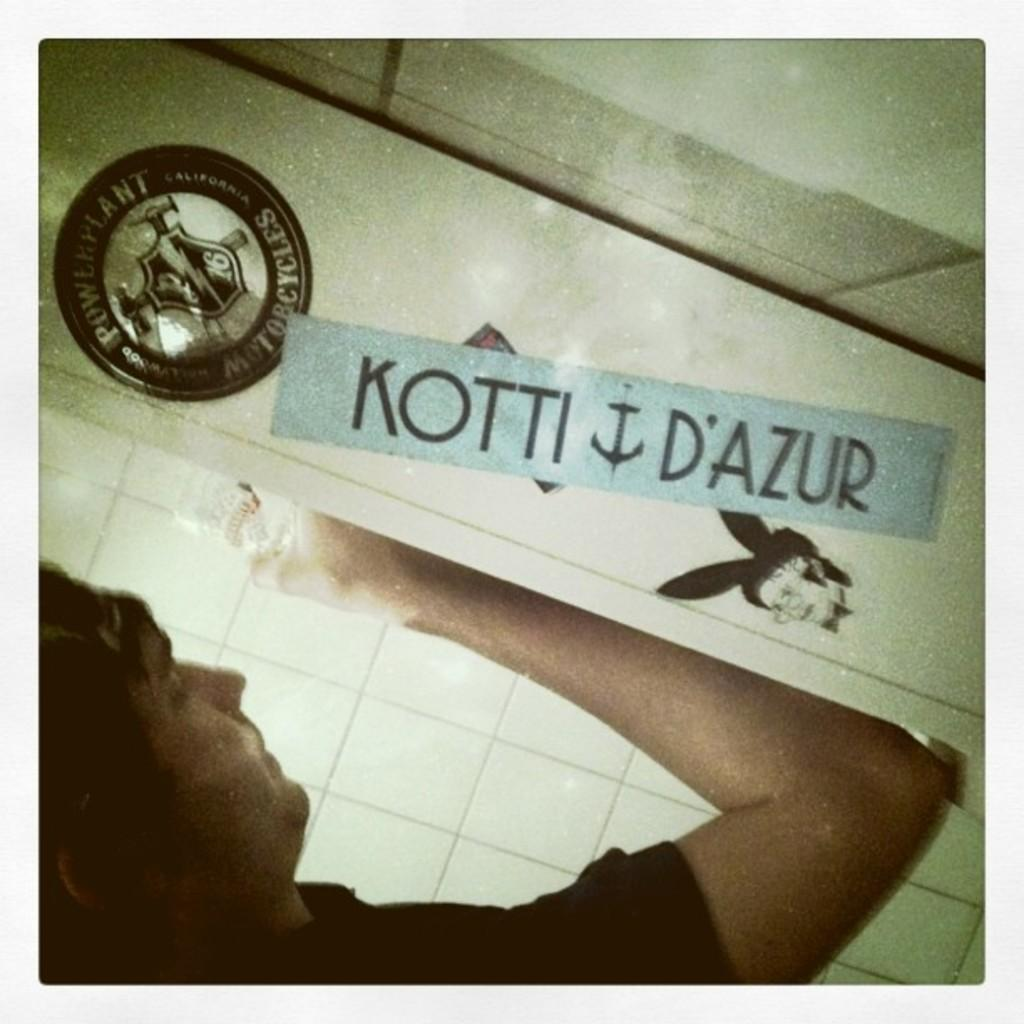What can be seen in the image? There is a person in the image. What is the person wearing? The person is wearing a black dress. What is the person holding in their hand? The person is holding an object in their hand. What color is the board in the image? There is a blue colored board in the image. What type of badge can be seen in the image? There is a black colored badge in the image. What other objects are visible in the image? There are other objects visible in the image. How many bricks are stacked on the agreement in the image? There is no agreement or bricks present in the image. What type of sticks are being used to stir the black colored badge in the image? There is no stirring or sticks present in the image; the badge is simply visible. 